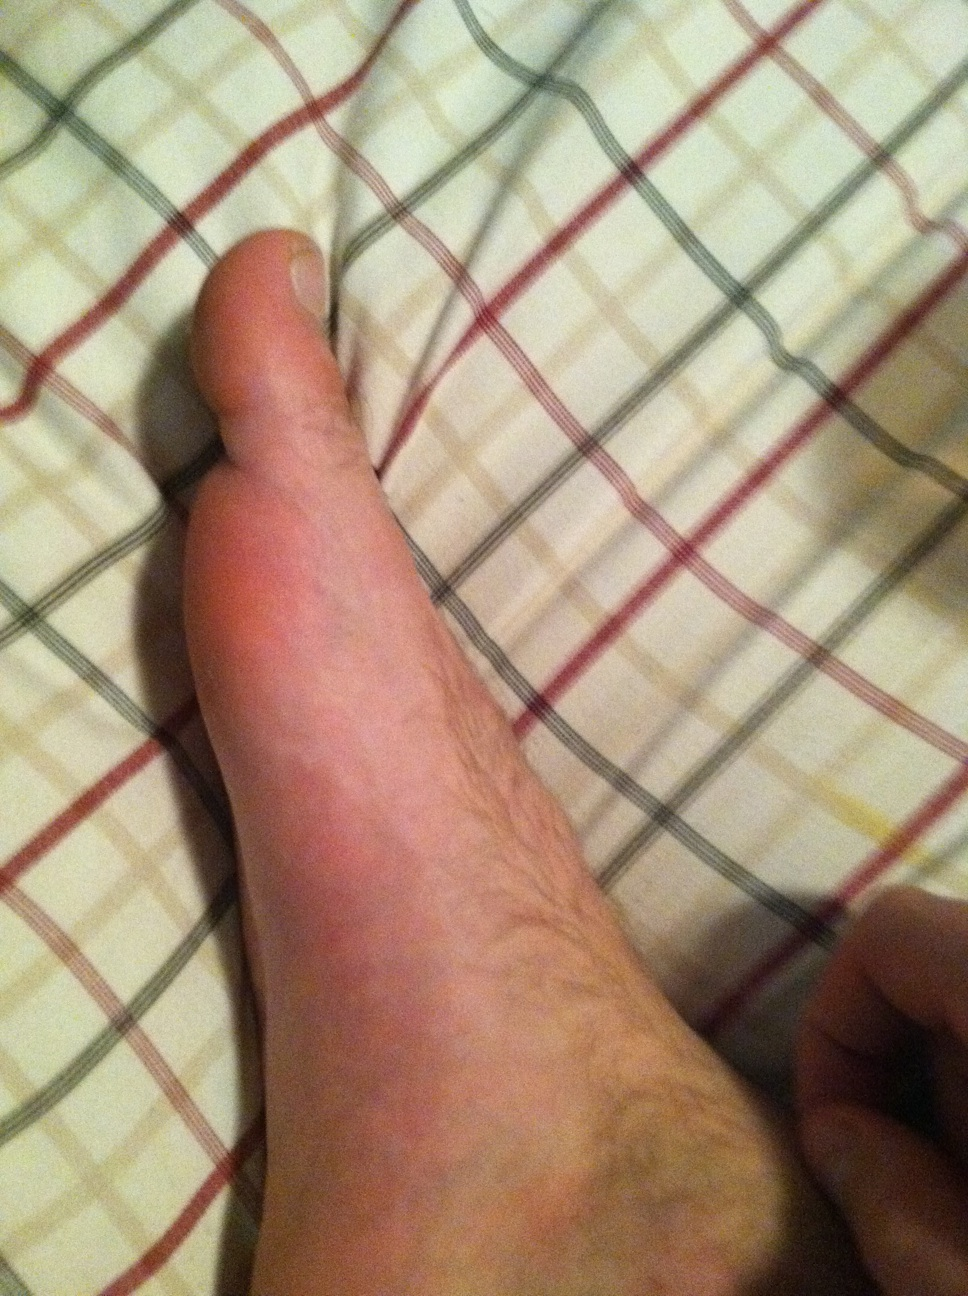Can you describe any notable features or details in this image? The image shows a close-up view of an arm lying on a checkered patterned surface, possibly a bedsheet. The checkered pattern consists of red and gray lines with a white background. The hair on the arm is light brown, and the skin appears lightly flushed, suggesting either warmth or recent pressure was applied to the area. No tattoos or jewelry are visible. 